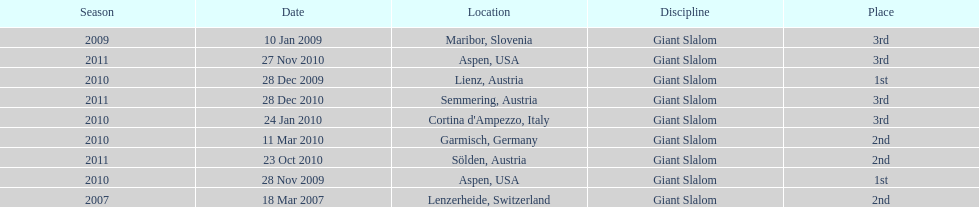Aspen and lienz in 2009 are the only races where this racer got what position? 1st. 